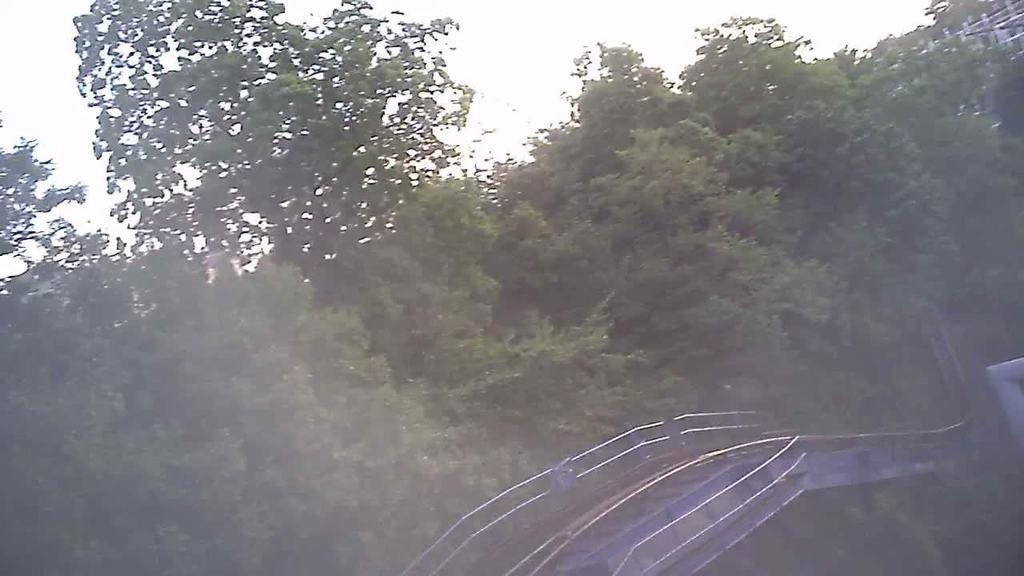What type of natural elements can be seen in the image? There are trees in the image. What man-made structure is present in the image? There is a bridge in the image. What part of the natural environment is visible in the image? The sky is visible in the image. What type of list can be seen hanging from the bridge in the image? There is no list present in the image; it features trees, a bridge, and the sky. How does the grip of the trees affect the appearance of the bridge in the image? The grip of the trees does not affect the appearance of the bridge in the image, as there is no interaction between the trees and the bridge. 